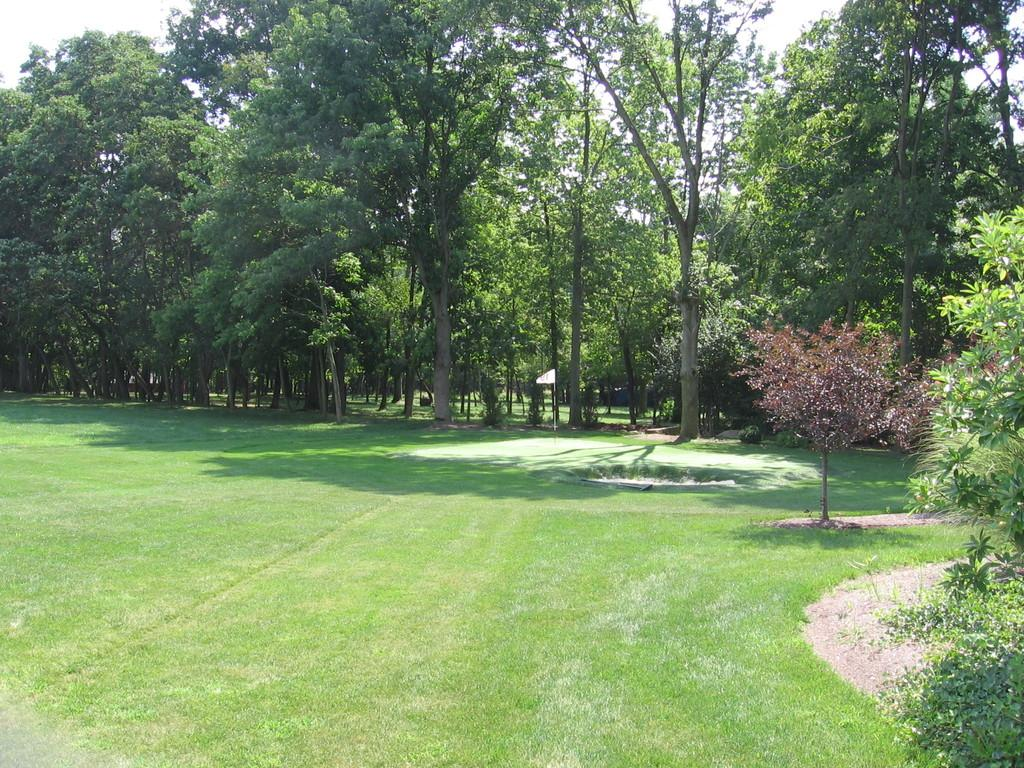What type of vegetation is present on the ground in the center of the image? There is grass on the ground in the center of the image. What can be seen in the background of the image? There are trees in the background of the image. What is located on the right side of the image in the foreground? There are leaves on the right side of the image in the foreground. What type of advice can be seen written on the board in the image? There is no board present in the image, so no advice can be seen. How does the pollution affect the trees in the image? There is no mention of pollution in the image, so its effect on the trees cannot be determined. 